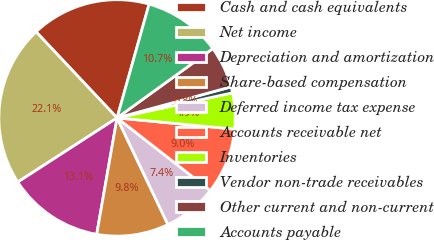<chart> <loc_0><loc_0><loc_500><loc_500><pie_chart><fcel>Cash and cash equivalents<fcel>Net income<fcel>Depreciation and amortization<fcel>Share-based compensation<fcel>Deferred income tax expense<fcel>Accounts receivable net<fcel>Inventories<fcel>Vendor non-trade receivables<fcel>Other current and non-current<fcel>Accounts payable<nl><fcel>16.39%<fcel>22.12%<fcel>13.11%<fcel>9.84%<fcel>7.38%<fcel>9.02%<fcel>4.92%<fcel>0.83%<fcel>5.74%<fcel>10.66%<nl></chart> 